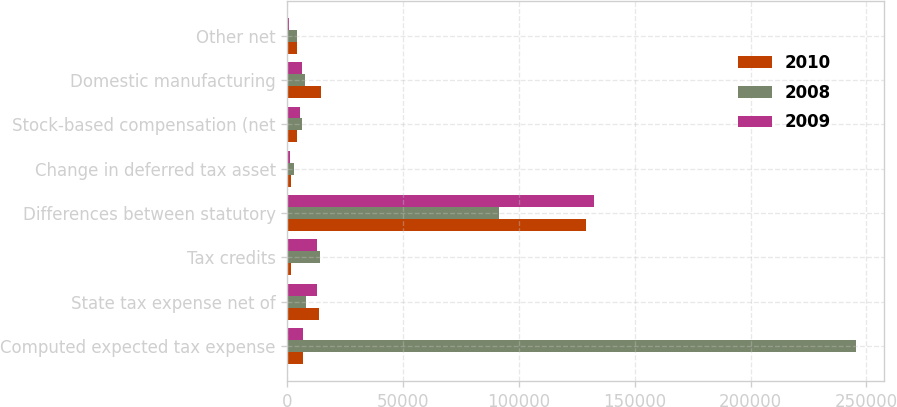Convert chart. <chart><loc_0><loc_0><loc_500><loc_500><stacked_bar_chart><ecel><fcel>Computed expected tax expense<fcel>State tax expense net of<fcel>Tax credits<fcel>Differences between statutory<fcel>Change in deferred tax asset<fcel>Stock-based compensation (net<fcel>Domestic manufacturing<fcel>Other net<nl><fcel>2010<fcel>6912.5<fcel>13444<fcel>1317<fcel>129063<fcel>1408<fcel>4181<fcel>14630<fcel>4098<nl><fcel>2008<fcel>245532<fcel>7799<fcel>14127<fcel>91262<fcel>2759<fcel>6085<fcel>7525<fcel>4050<nl><fcel>2009<fcel>6912.5<fcel>12700<fcel>12873<fcel>132470<fcel>1105<fcel>5457<fcel>6300<fcel>870<nl></chart> 